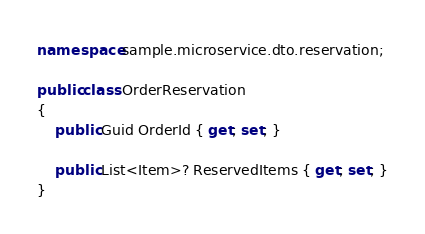<code> <loc_0><loc_0><loc_500><loc_500><_C#_>namespace sample.microservice.dto.reservation;

public class OrderReservation
{
    public Guid OrderId { get; set; }

    public List<Item>? ReservedItems { get; set; }
}
</code> 